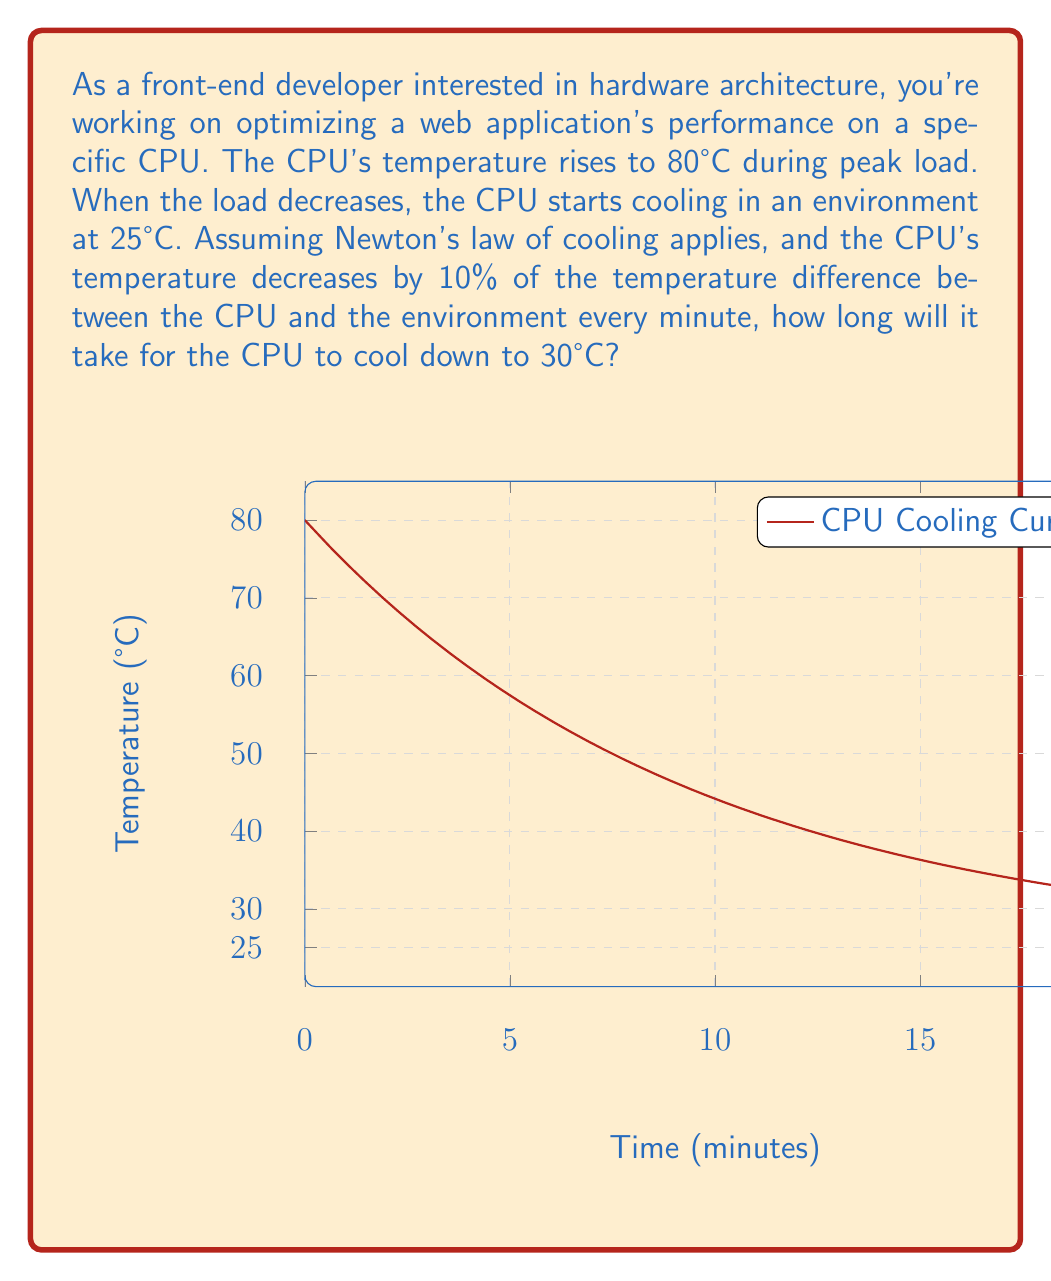Show me your answer to this math problem. Let's approach this step-by-step using Newton's law of cooling:

1) Newton's law of cooling states that the rate of change of the temperature of an object is proportional to the difference between its own temperature and the ambient temperature.

2) Let $T(t)$ be the temperature of the CPU at time $t$, and $T_a$ be the ambient temperature. The differential equation is:

   $$\frac{dT}{dt} = -k(T - T_a)$$

   where $k$ is the cooling constant.

3) We're given that the temperature decreases by 10% of the difference every minute. This means:

   $$T(1) - T_a = 0.9(T(0) - T_a)$$

4) Using this, we can find $k$:

   $$e^{-k} = 0.9$$
   $$k = -\ln(0.9) \approx 0.1054$$

5) The solution to the differential equation is:

   $$T(t) = T_a + (T_0 - T_a)e^{-kt}$$

   where $T_0$ is the initial temperature.

6) Plugging in our values:

   $$T(t) = 25 + (80 - 25)e^{-0.1054t} = 25 + 55e^{-0.1054t}$$

7) To find when the CPU reaches 30°C, we solve:

   $$30 = 25 + 55e^{-0.1054t}$$
   $$5 = 55e^{-0.1054t}$$
   $$\ln(1/11) = -0.1054t$$
   $$t = \frac{-\ln(1/11)}{0.1054} \approx 18.95$$

Therefore, it will take approximately 18.95 minutes for the CPU to cool to 30°C.
Answer: 18.95 minutes 